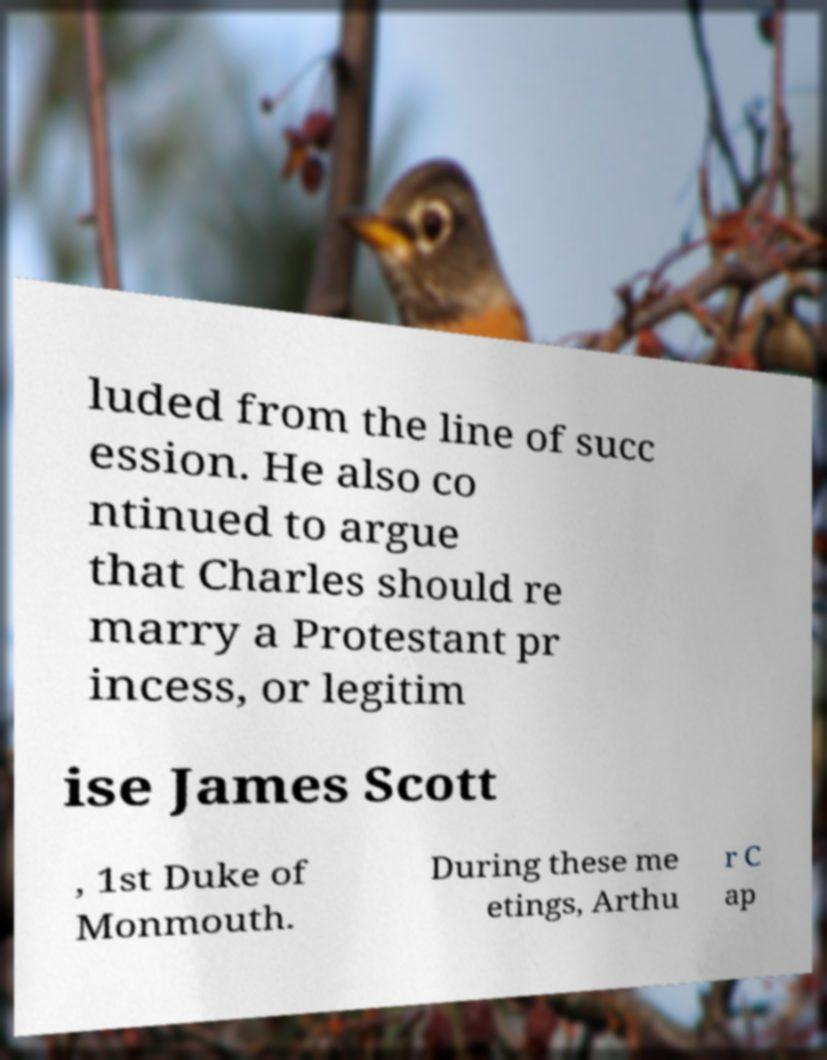Please identify and transcribe the text found in this image. luded from the line of succ ession. He also co ntinued to argue that Charles should re marry a Protestant pr incess, or legitim ise James Scott , 1st Duke of Monmouth. During these me etings, Arthu r C ap 